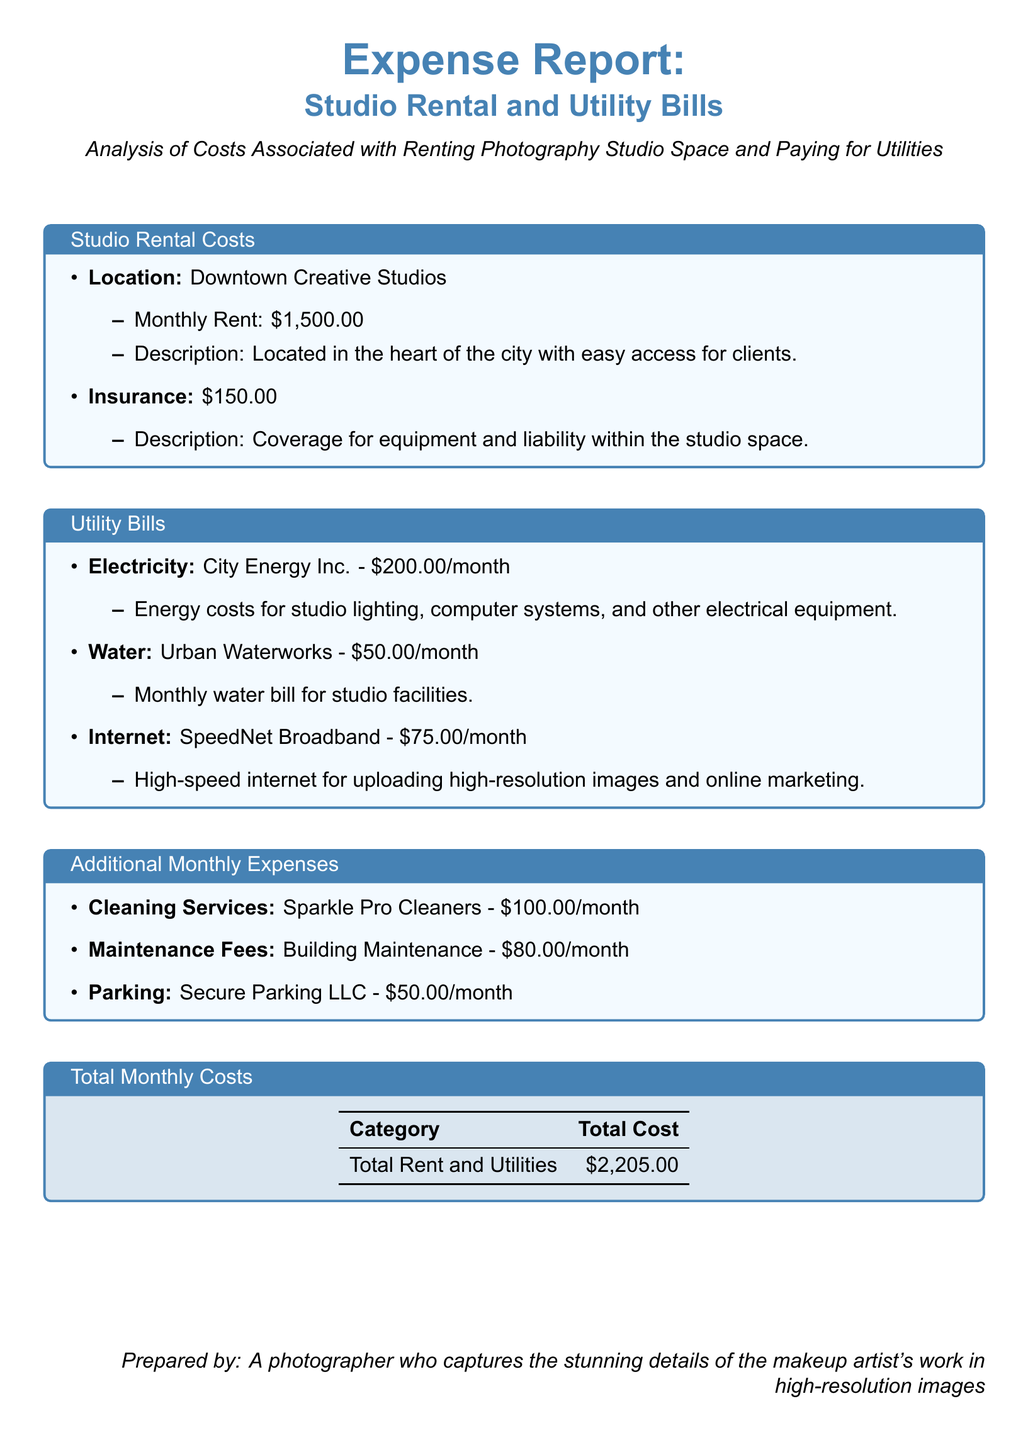What is the monthly rent for the studio? The monthly rent for the studio is explicitly stated in the document as $1,500.00.
Answer: $1,500.00 How much is the insurance cost? The document specifies that the insurance cost is $150.00.
Answer: $150.00 What is the total cost for electricity per month? The total cost for electricity is indicated as $200.00/month in the utility bills section.
Answer: $200.00 How much does the cleaning service cost monthly? The monthly cost for cleaning services is presented in the additional expenses section as $100.00.
Answer: $100.00 What is the total monthly cost for rent and utilities? The total monthly cost for rent and utilities is calculated and summarized in the document as $2,205.00.
Answer: $2,205.00 What is the total spent on water monthly? The document states that the total monthly water bill is $50.00.
Answer: $50.00 Which company provides internet services for the studio? The document notes that the internet service provider is SpeedNet Broadband.
Answer: SpeedNet Broadband Why is high-speed internet important for the studio? The reasoning is found in the description, which mentions the need for uploading high-resolution images and online marketing.
Answer: Uploading high-resolution images and online marketing What are the additional monthly expenses listed? The additional monthly expenses include cleaning services, maintenance fees, and parking.
Answer: Cleaning services, maintenance fees, and parking 